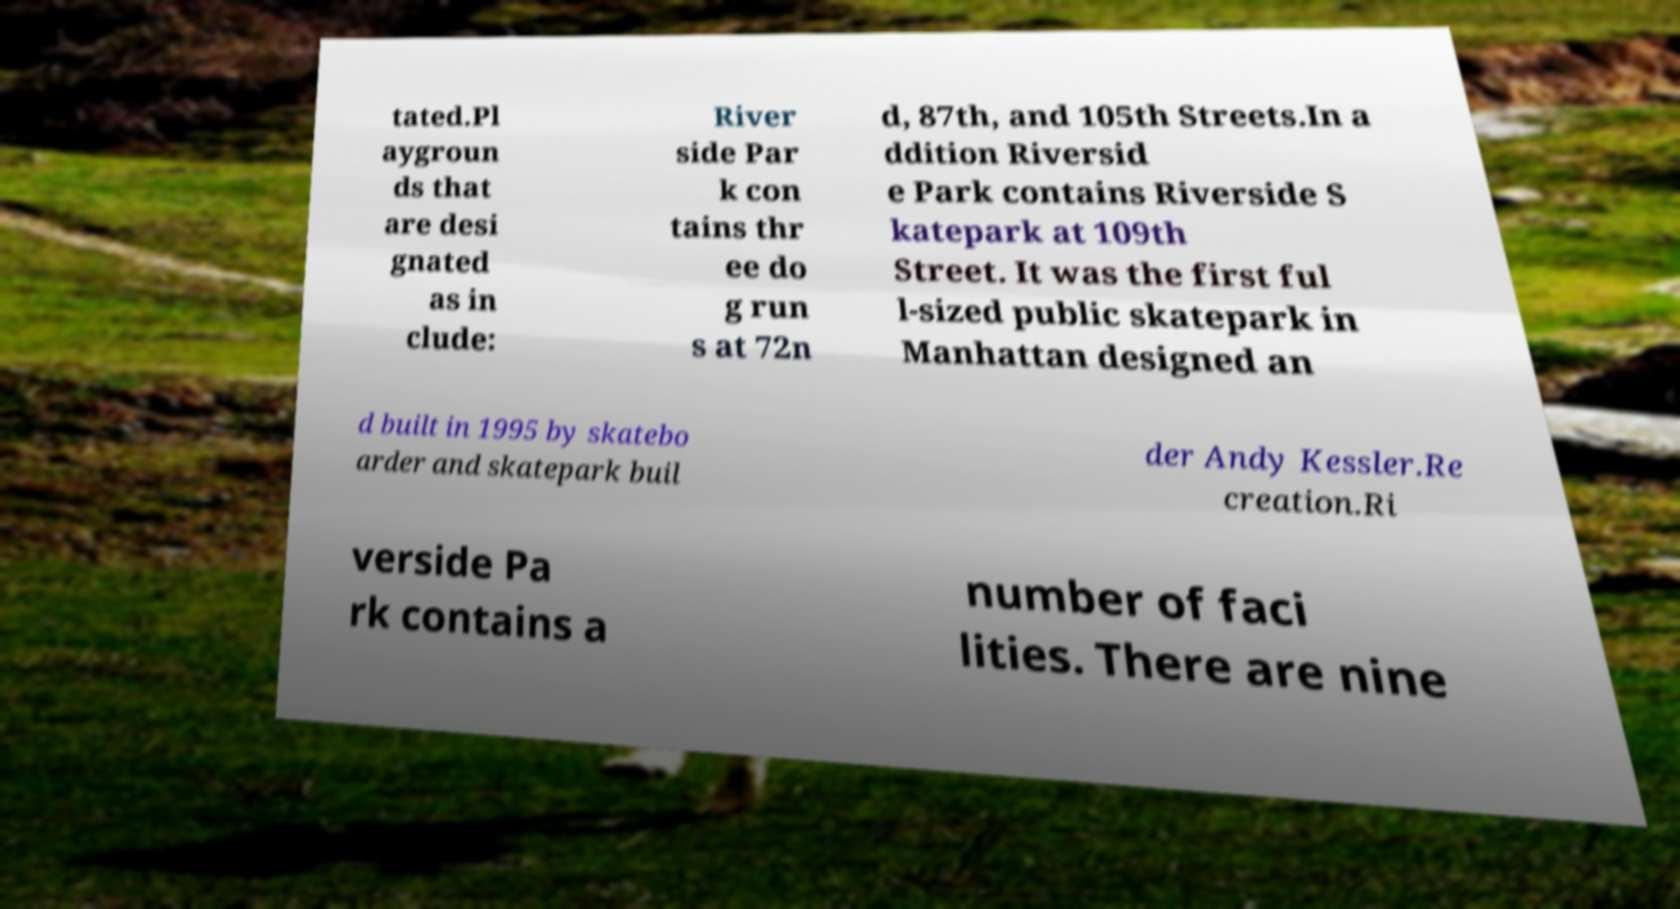Please identify and transcribe the text found in this image. tated.Pl aygroun ds that are desi gnated as in clude: River side Par k con tains thr ee do g run s at 72n d, 87th, and 105th Streets.In a ddition Riversid e Park contains Riverside S katepark at 109th Street. It was the first ful l-sized public skatepark in Manhattan designed an d built in 1995 by skatebo arder and skatepark buil der Andy Kessler.Re creation.Ri verside Pa rk contains a number of faci lities. There are nine 